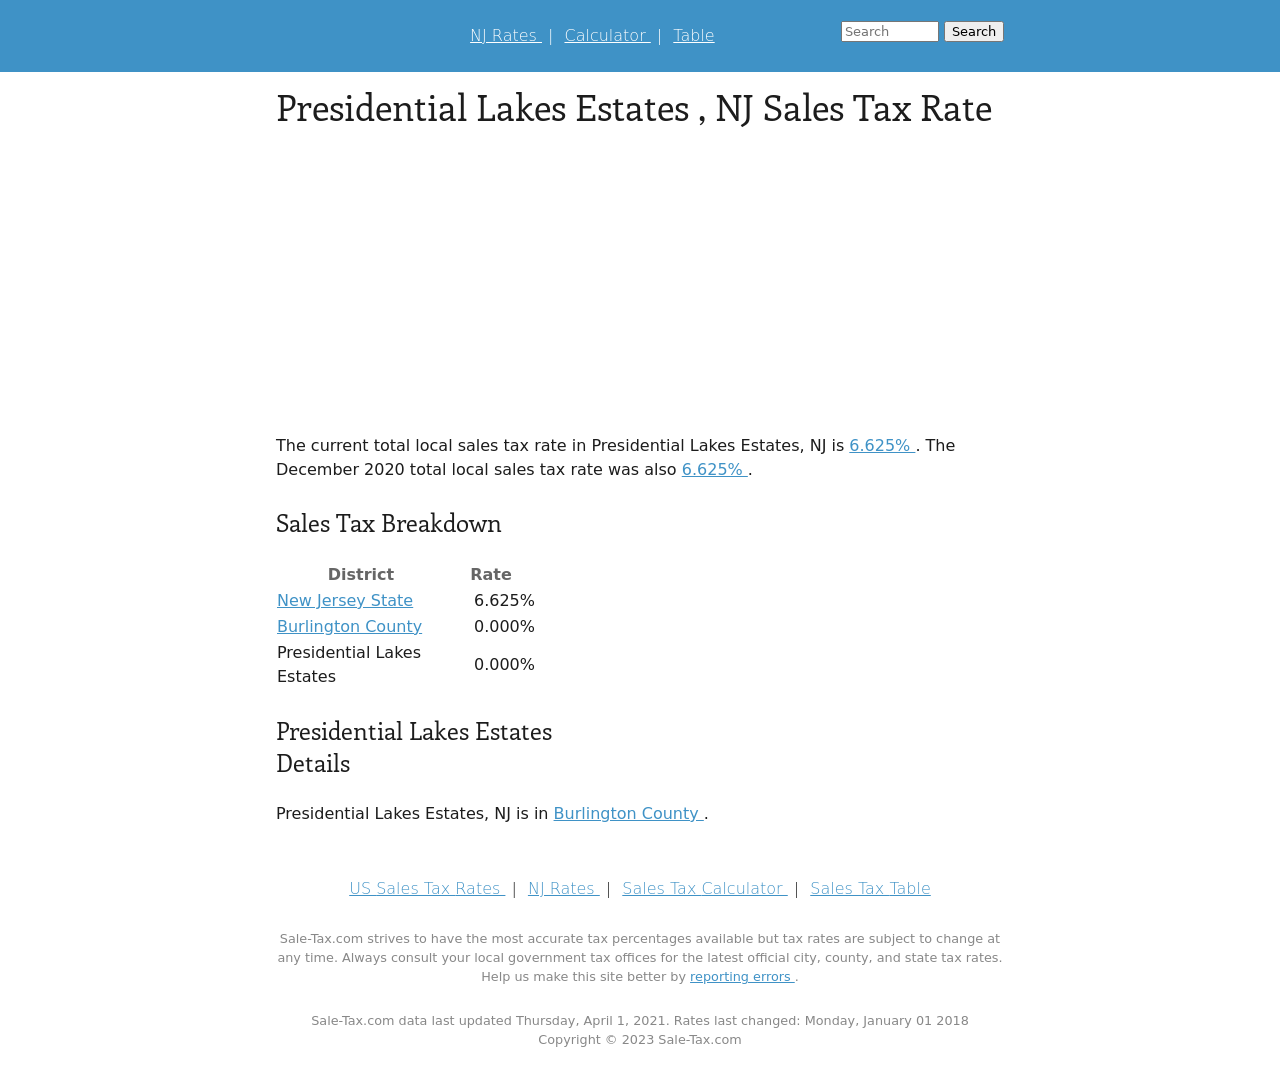What are the implications of a 0% sales tax rate in Burlington County, as shown in the image? A 0% sales tax rate in Burlington County, as depicted, suggests that consumers and businesses in Presidential Lakes Estates do not pay local sales tax on top of the New Jersey state tax. This could make the area more attractive for business investments and retail purchases, possibly stimulating economic activity by attracting both consumers and businesses looking for lower tax burdens. 